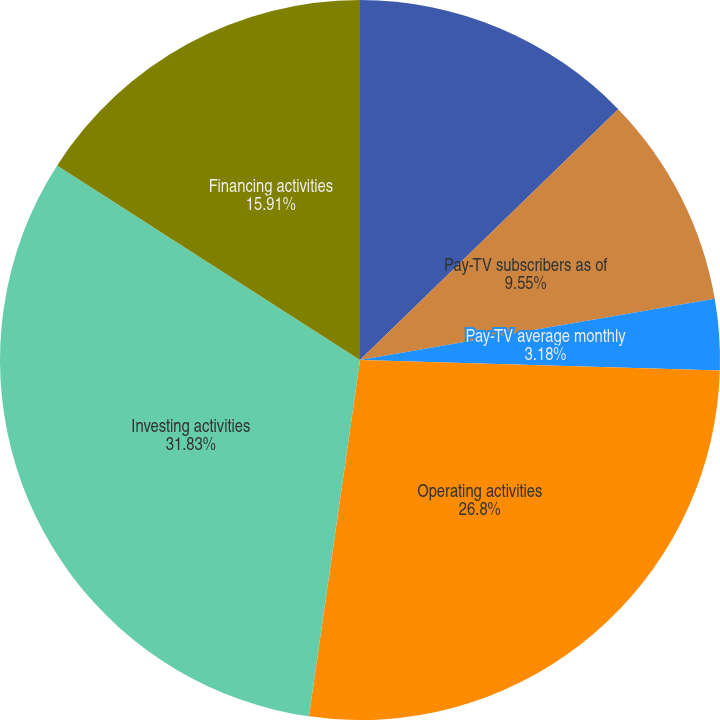Convert chart. <chart><loc_0><loc_0><loc_500><loc_500><pie_chart><fcel>Other Data (Unaudited except<fcel>Pay-TV subscribers as of<fcel>Pay-TV subscriber additions<fcel>Pay-TV average monthly<fcel>Operating activities<fcel>Investing activities<fcel>Financing activities<nl><fcel>12.73%<fcel>9.55%<fcel>0.0%<fcel>3.18%<fcel>26.8%<fcel>31.82%<fcel>15.91%<nl></chart> 